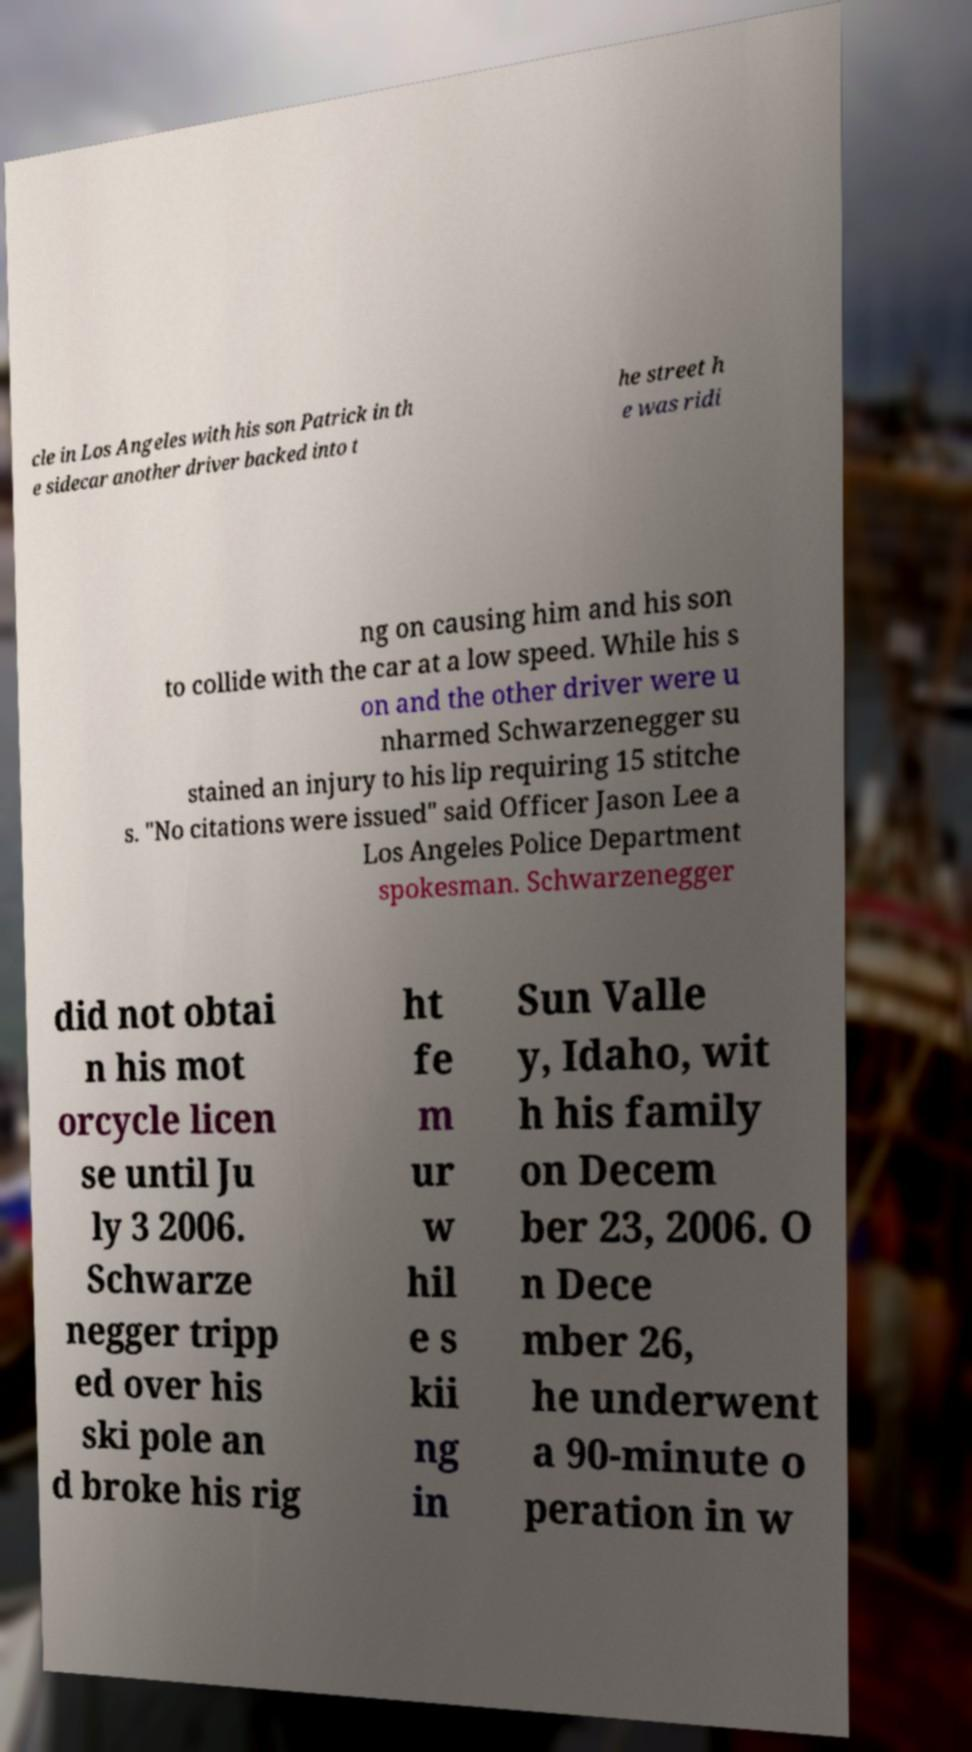There's text embedded in this image that I need extracted. Can you transcribe it verbatim? cle in Los Angeles with his son Patrick in th e sidecar another driver backed into t he street h e was ridi ng on causing him and his son to collide with the car at a low speed. While his s on and the other driver were u nharmed Schwarzenegger su stained an injury to his lip requiring 15 stitche s. "No citations were issued" said Officer Jason Lee a Los Angeles Police Department spokesman. Schwarzenegger did not obtai n his mot orcycle licen se until Ju ly 3 2006. Schwarze negger tripp ed over his ski pole an d broke his rig ht fe m ur w hil e s kii ng in Sun Valle y, Idaho, wit h his family on Decem ber 23, 2006. O n Dece mber 26, he underwent a 90-minute o peration in w 